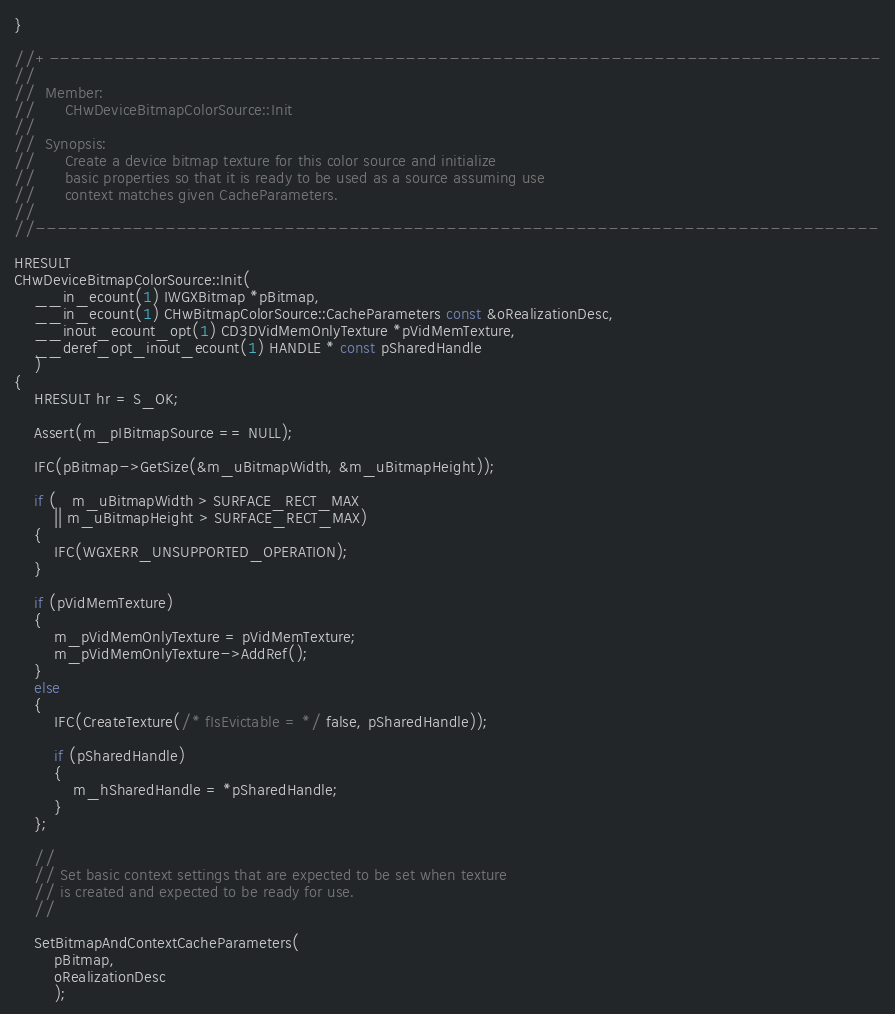Convert code to text. <code><loc_0><loc_0><loc_500><loc_500><_C++_>}

//+-----------------------------------------------------------------------------
//
//  Member:
//      CHwDeviceBitmapColorSource::Init
//
//  Synopsis:
//      Create a device bitmap texture for this color source and initialize
//      basic properties so that it is ready to be used as a source assuming use
//      context matches given CacheParameters.
//
//------------------------------------------------------------------------------

HRESULT
CHwDeviceBitmapColorSource::Init(
    __in_ecount(1) IWGXBitmap *pBitmap,
    __in_ecount(1) CHwBitmapColorSource::CacheParameters const &oRealizationDesc,
    __inout_ecount_opt(1) CD3DVidMemOnlyTexture *pVidMemTexture,
    __deref_opt_inout_ecount(1) HANDLE * const pSharedHandle
    )
{
    HRESULT hr = S_OK;

    Assert(m_pIBitmapSource == NULL);

    IFC(pBitmap->GetSize(&m_uBitmapWidth, &m_uBitmapHeight));

    if (   m_uBitmapWidth > SURFACE_RECT_MAX
        || m_uBitmapHeight > SURFACE_RECT_MAX)
    {
        IFC(WGXERR_UNSUPPORTED_OPERATION);
    }

    if (pVidMemTexture)
    {
        m_pVidMemOnlyTexture = pVidMemTexture;
        m_pVidMemOnlyTexture->AddRef();
    }
    else
    {
        IFC(CreateTexture(/* fIsEvictable = */ false, pSharedHandle));
        
        if (pSharedHandle)
        {
            m_hSharedHandle = *pSharedHandle;
        }
    };

    //
    // Set basic context settings that are expected to be set when texture
    // is created and expected to be ready for use.
    //

    SetBitmapAndContextCacheParameters(
        pBitmap,
        oRealizationDesc
        );
</code> 